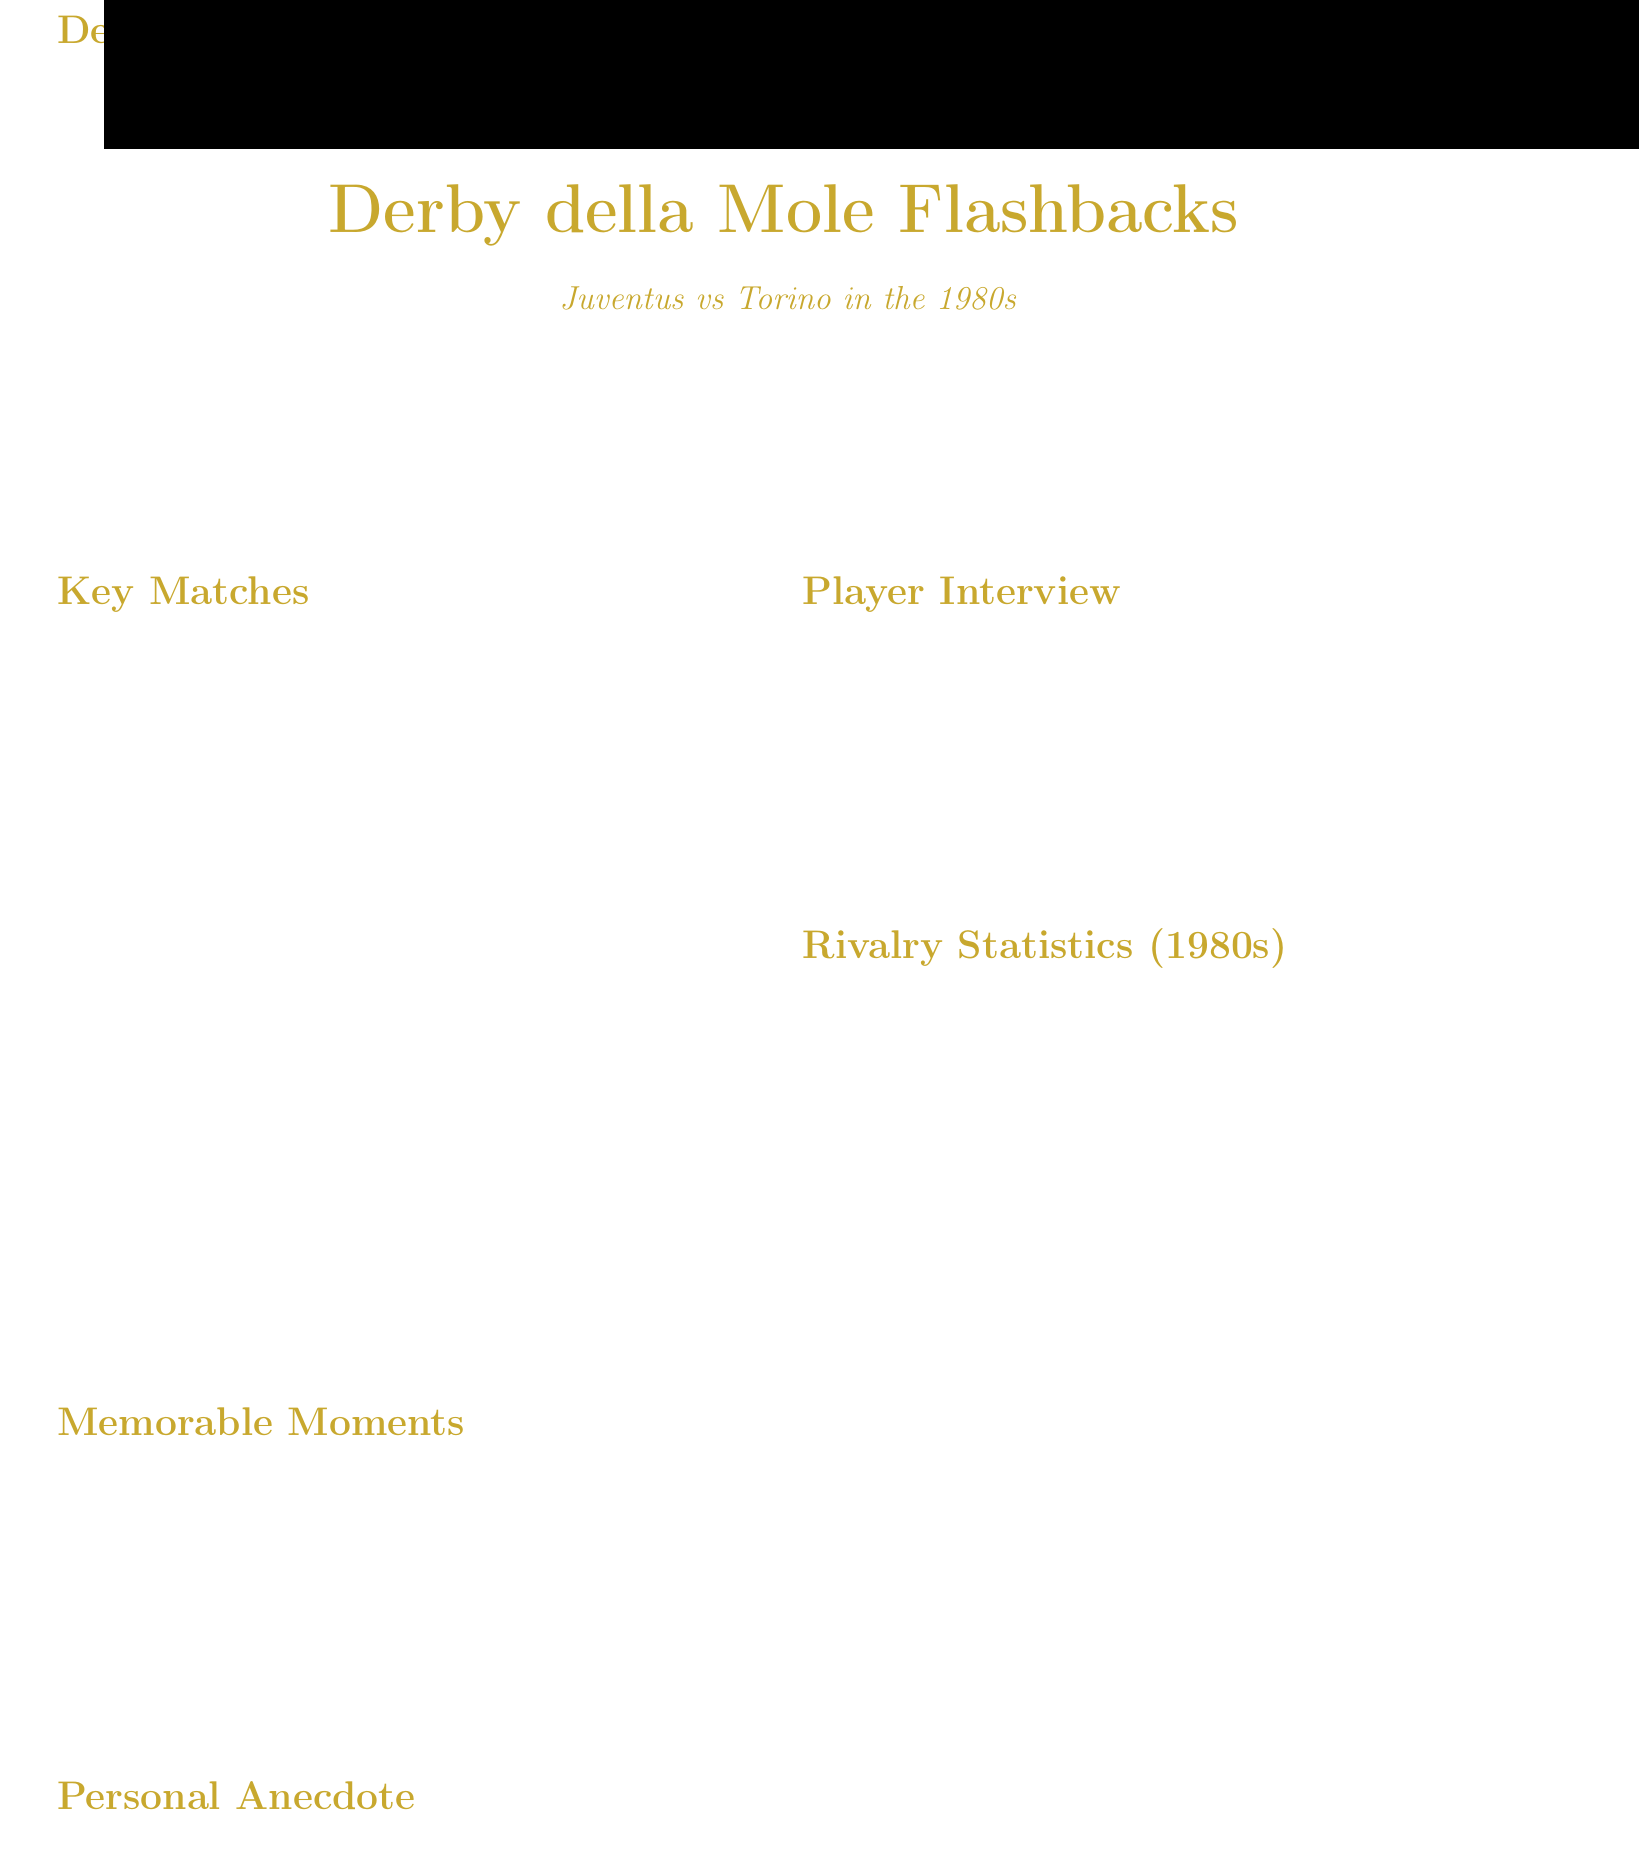what was the score of the match on November 16, 1980? The score for the match on November 16, 1980, is specified in the document.
Answer: Juventus 2 - 1 Torino who scored a hat-trick for Torino in the April 5, 1983 match? The document mentions the player who scored a hat-trick for Torino during this match.
Answer: Aldo Serena how many total matches were played between Juventus and Torino in the 1980s? The total number of matches played in the rivalry during the 1980s is provided in the statistics section.
Answer: 20 which player is quoted in the player interview section? The document cites a player who shares thoughts about the Derby della Mole in the interview section.
Answer: Gaetano Scirea what year did Michel Platini score a memorable free-kick? The document highlights a specific year associated with Michel Platini's memorable free-kick.
Answer: 1984 what was the outcome of the April 5, 1983 match? The document describes the result of the match, which is important for understanding the rivalry.
Answer: Torino 3 - 2 Juventus how many goals did Juventus score in the 1980s derbies according to the statistics? The statistics section mentions the total goals Juventus scored against Torino in the specified period.
Answer: 32 what was the legacy of the 1980s derbies according to the document? The legacy mentions the impact those matches had on future encounters and club history.
Answer: Standard of excellence 